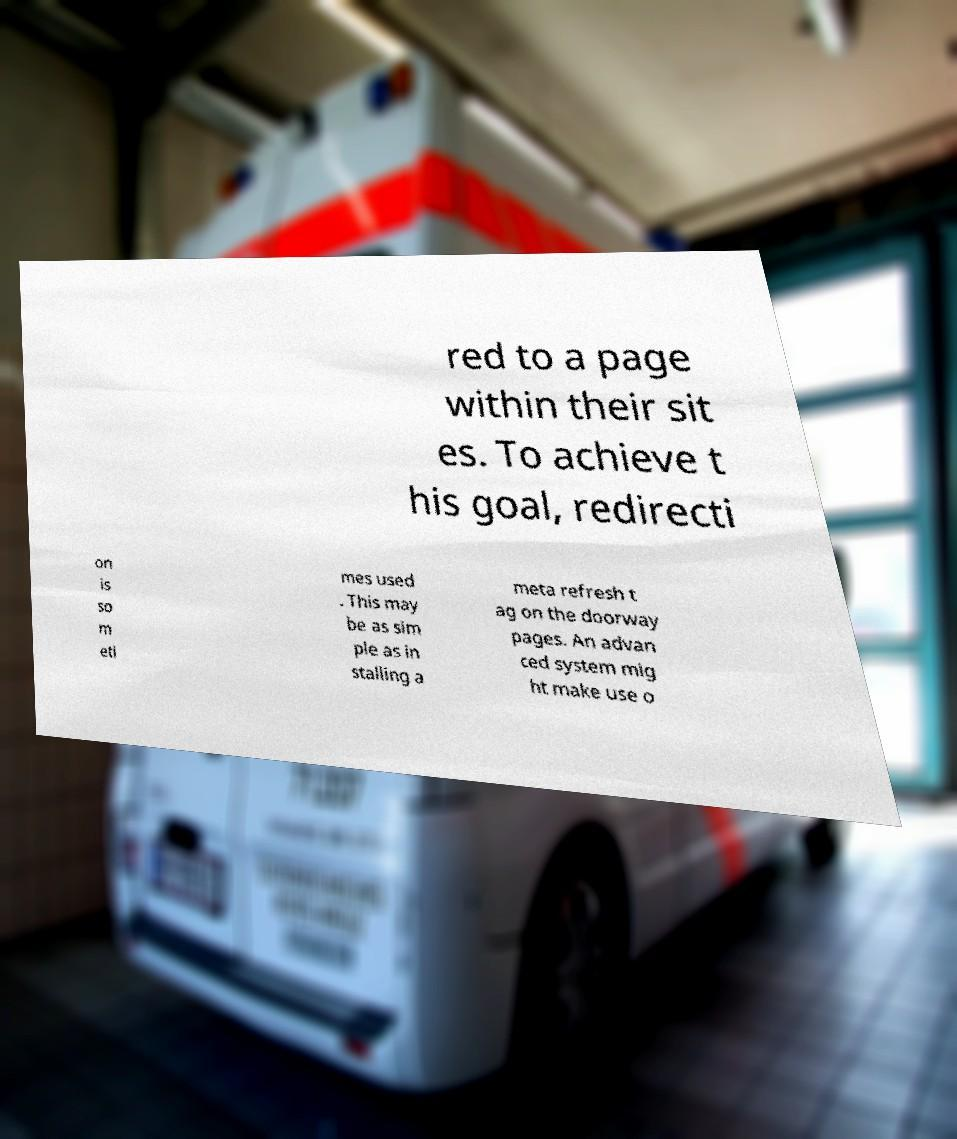There's text embedded in this image that I need extracted. Can you transcribe it verbatim? red to a page within their sit es. To achieve t his goal, redirecti on is so m eti mes used . This may be as sim ple as in stalling a meta refresh t ag on the doorway pages. An advan ced system mig ht make use o 